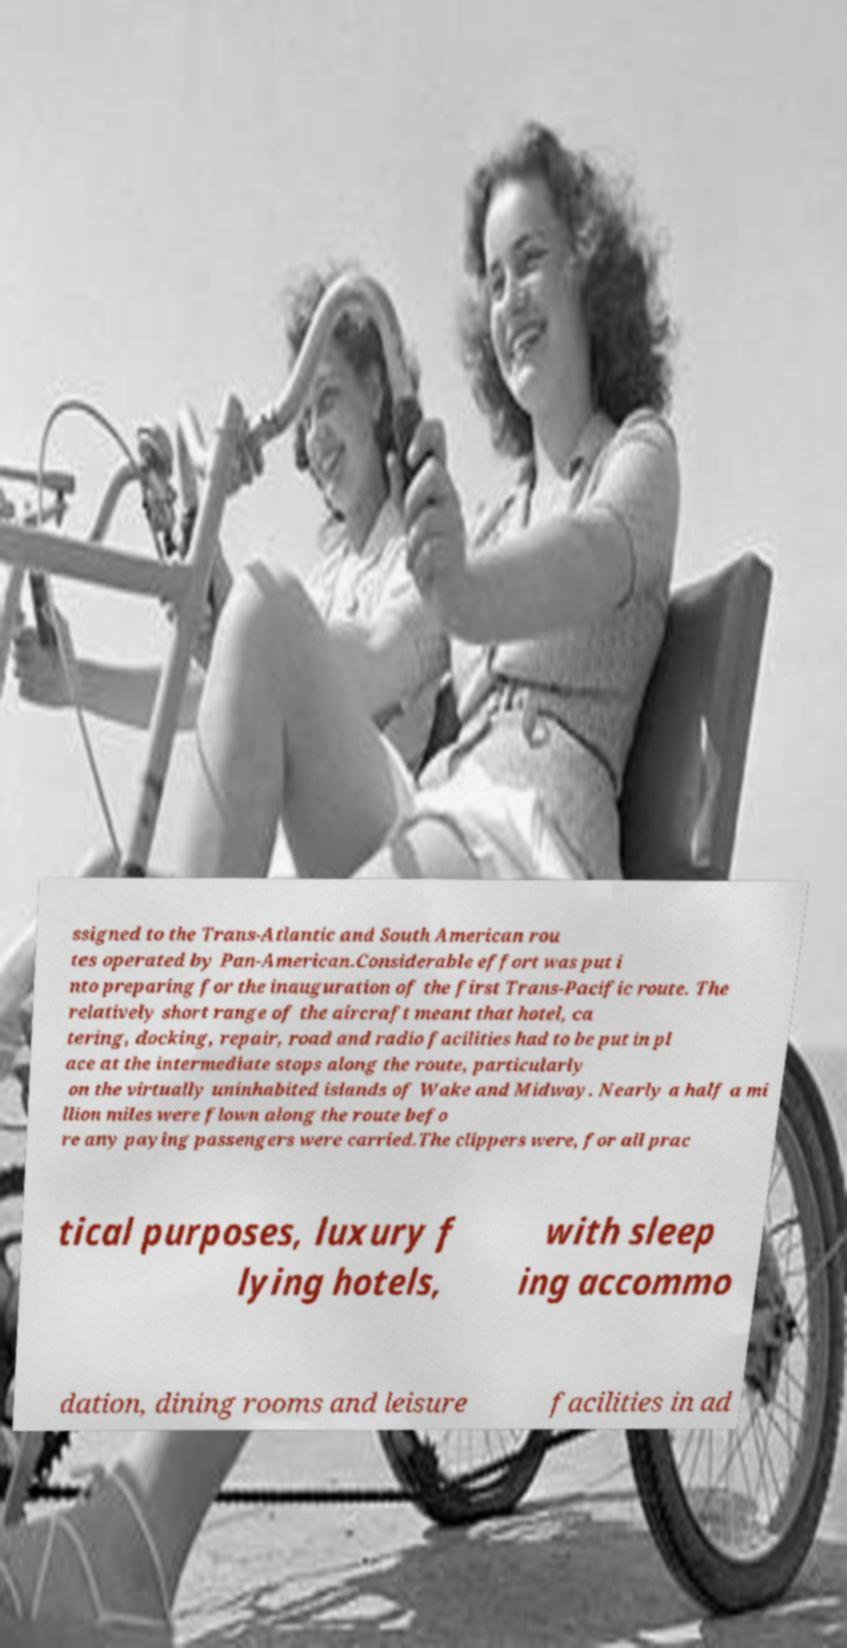Can you accurately transcribe the text from the provided image for me? ssigned to the Trans-Atlantic and South American rou tes operated by Pan-American.Considerable effort was put i nto preparing for the inauguration of the first Trans-Pacific route. The relatively short range of the aircraft meant that hotel, ca tering, docking, repair, road and radio facilities had to be put in pl ace at the intermediate stops along the route, particularly on the virtually uninhabited islands of Wake and Midway. Nearly a half a mi llion miles were flown along the route befo re any paying passengers were carried.The clippers were, for all prac tical purposes, luxury f lying hotels, with sleep ing accommo dation, dining rooms and leisure facilities in ad 